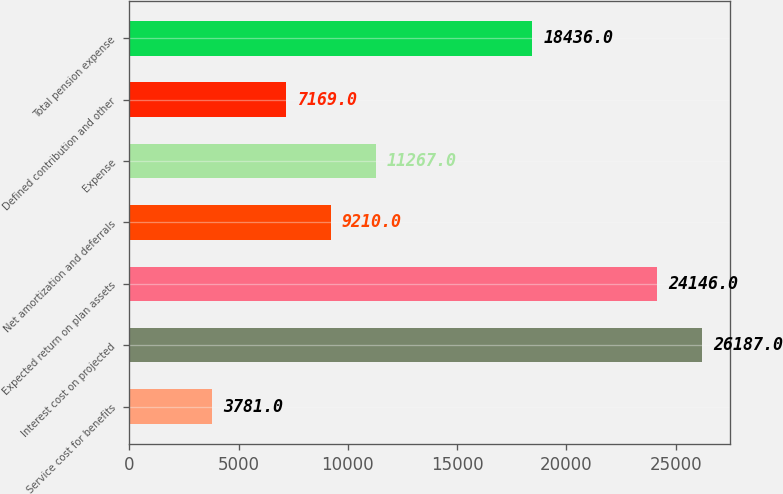Convert chart to OTSL. <chart><loc_0><loc_0><loc_500><loc_500><bar_chart><fcel>Service cost for benefits<fcel>Interest cost on projected<fcel>Expected return on plan assets<fcel>Net amortization and deferrals<fcel>Expense<fcel>Defined contribution and other<fcel>Total pension expense<nl><fcel>3781<fcel>26187<fcel>24146<fcel>9210<fcel>11267<fcel>7169<fcel>18436<nl></chart> 